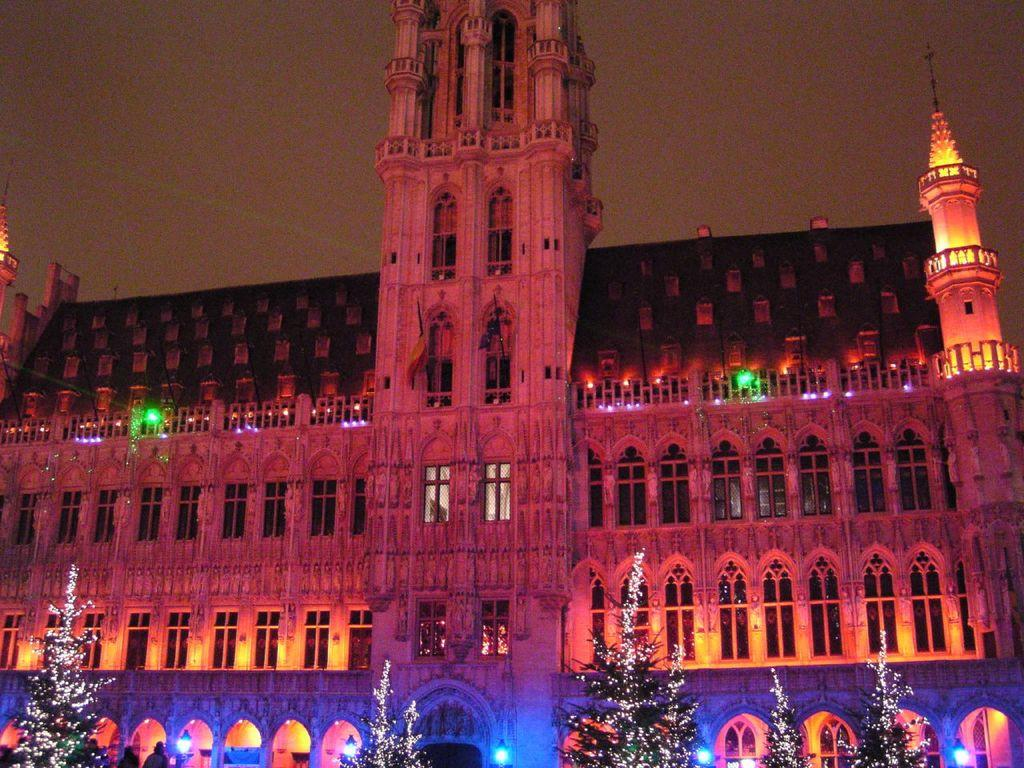What type of structure is present in the image? There is a building in the image. What other elements can be seen in the image besides the building? There are plants and lights visible in the image. What feature of the building is mentioned in the facts? The building has windows. What can be seen in the background of the image? The sky is visible in the background of the image. What type of lipstick is being applied to the building in the image? There is no lipstick or application of lipstick present in the image. 